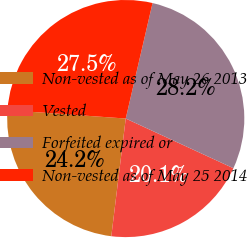<chart> <loc_0><loc_0><loc_500><loc_500><pie_chart><fcel>Non-vested as of May 26 2013<fcel>Vested<fcel>Forfeited expired or<fcel>Non-vested as of May 25 2014<nl><fcel>24.19%<fcel>20.06%<fcel>28.25%<fcel>27.5%<nl></chart> 